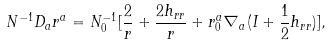<formula> <loc_0><loc_0><loc_500><loc_500>N ^ { - 1 } D _ { a } r ^ { a } = N _ { 0 } ^ { - 1 } [ \frac { 2 } { r } + \frac { 2 h _ { r r } } { r } + r _ { 0 } ^ { a } \nabla _ { a } ( I + \frac { 1 } { 2 } h _ { r r } ) ] ,</formula> 